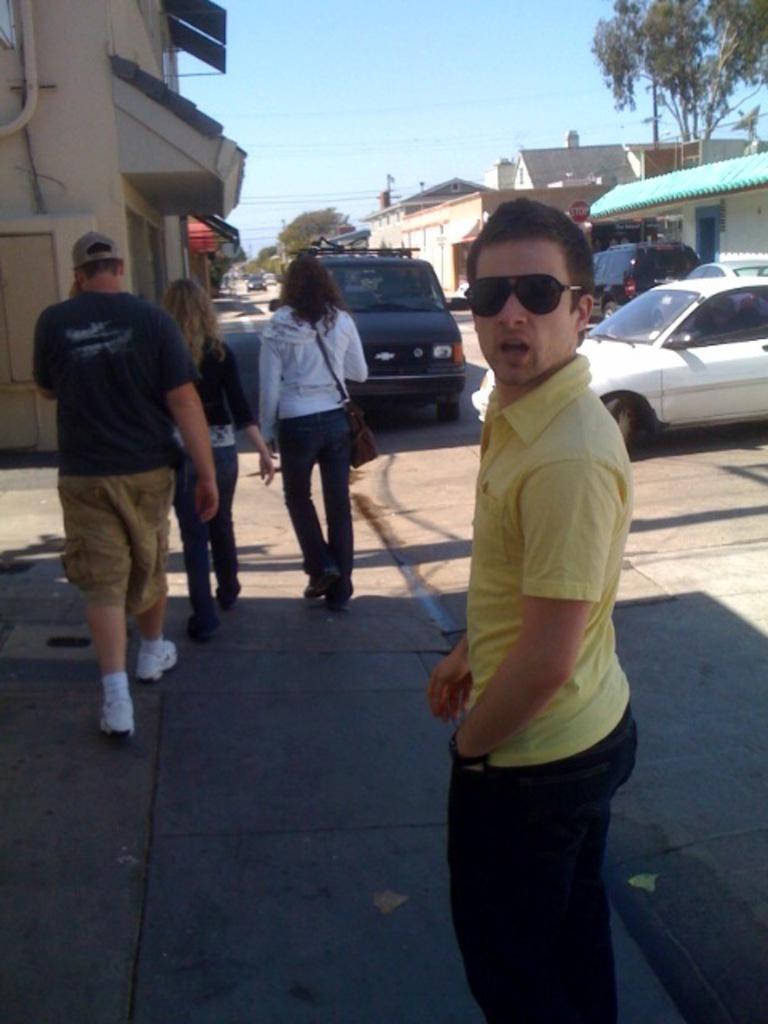How would you summarize this image in a sentence or two? In this image I can see group of people. In front the person is wearing yellow and black color dress and I can see few vehicles, buildings, trees in green color and the sky is in blue and white color. 